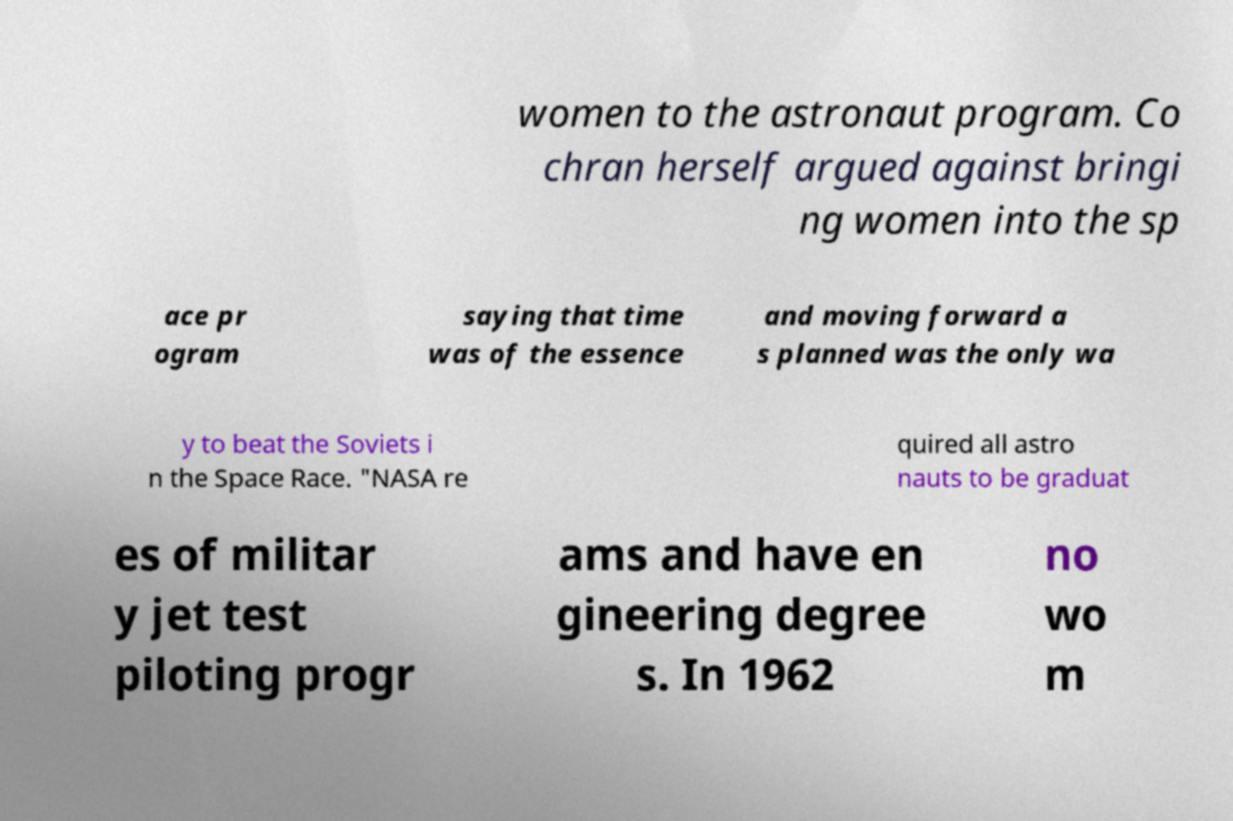For documentation purposes, I need the text within this image transcribed. Could you provide that? women to the astronaut program. Co chran herself argued against bringi ng women into the sp ace pr ogram saying that time was of the essence and moving forward a s planned was the only wa y to beat the Soviets i n the Space Race. "NASA re quired all astro nauts to be graduat es of militar y jet test piloting progr ams and have en gineering degree s. In 1962 no wo m 